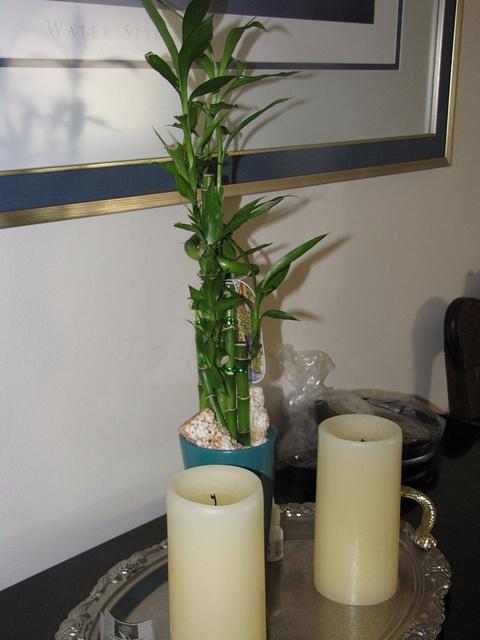Is that bamboo?
Answer briefly. Yes. How many species of plants are shown?
Be succinct. 1. How many candles are on the tray?
Keep it brief. 2. Where are the flowers?
Write a very short answer. Vase. Have these candles been burned before?
Be succinct. Yes. 